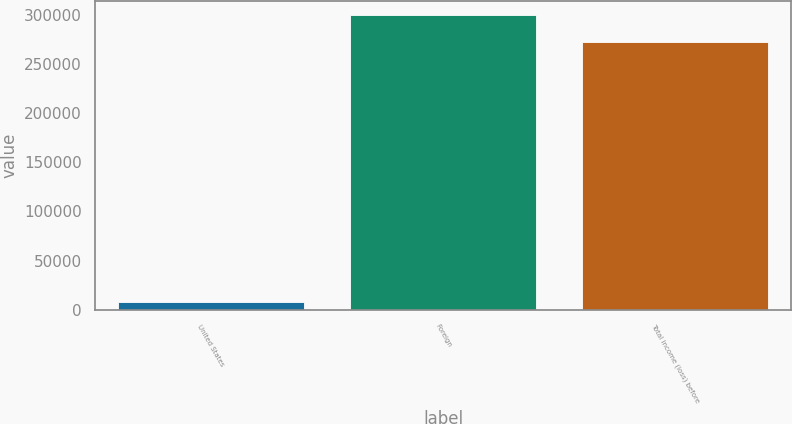<chart> <loc_0><loc_0><loc_500><loc_500><bar_chart><fcel>United States<fcel>Foreign<fcel>Total income (loss) before<nl><fcel>7638<fcel>299356<fcel>272142<nl></chart> 